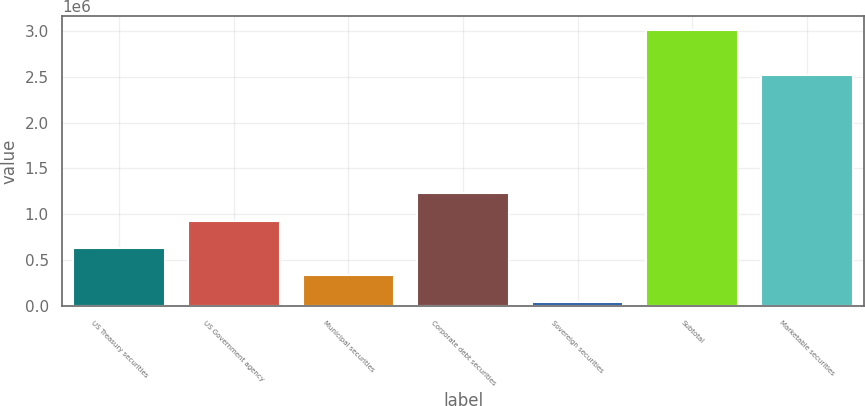Convert chart. <chart><loc_0><loc_0><loc_500><loc_500><bar_chart><fcel>US Treasury securities<fcel>US Government agency<fcel>Municipal securities<fcel>Corporate debt securities<fcel>Sovereign securities<fcel>Subtotal<fcel>Marketable securities<nl><fcel>635424<fcel>932022<fcel>338825<fcel>1.22862e+06<fcel>42227<fcel>3.00821e+06<fcel>2.51757e+06<nl></chart> 